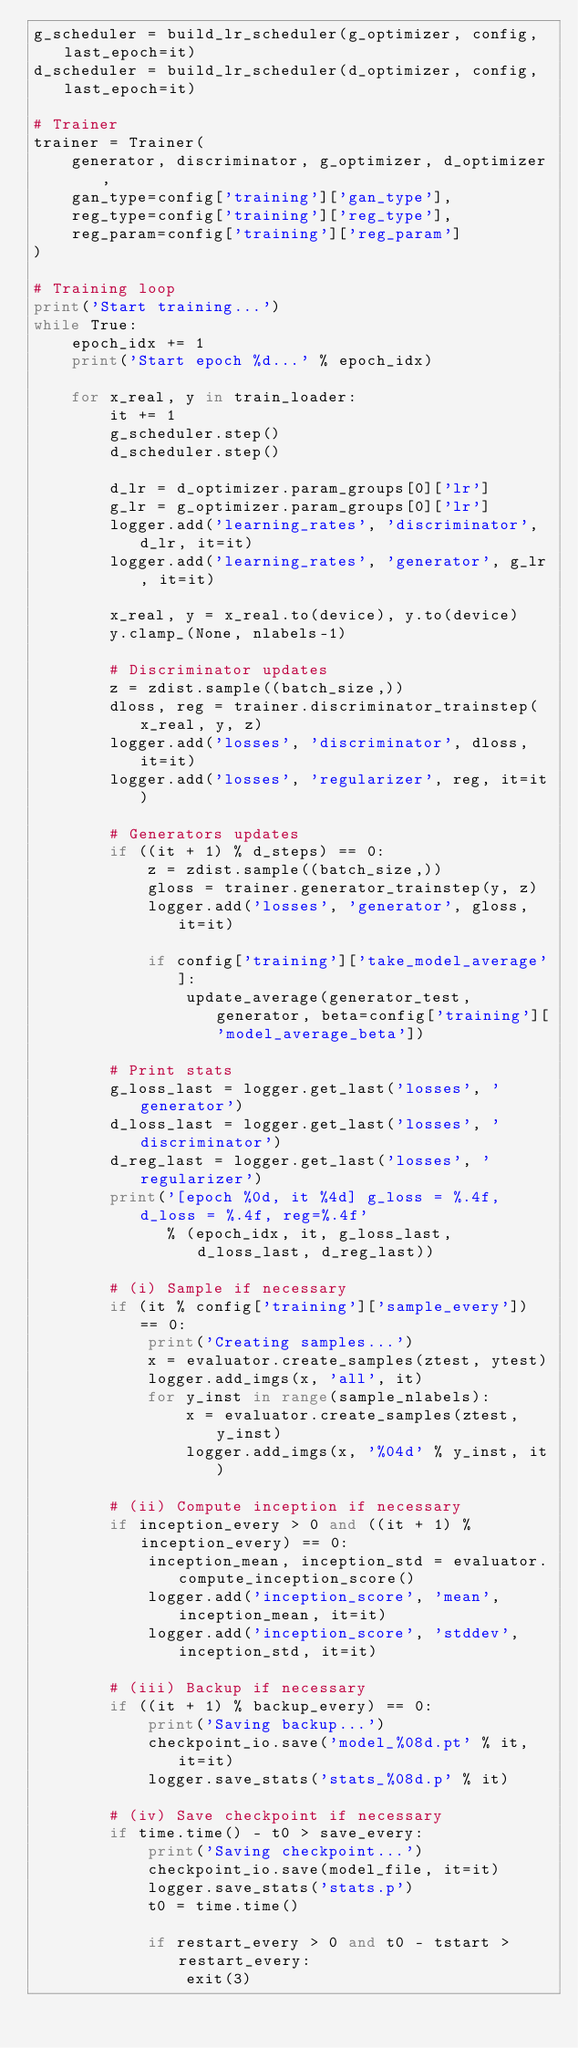Convert code to text. <code><loc_0><loc_0><loc_500><loc_500><_Python_>g_scheduler = build_lr_scheduler(g_optimizer, config, last_epoch=it)
d_scheduler = build_lr_scheduler(d_optimizer, config, last_epoch=it)

# Trainer
trainer = Trainer(
    generator, discriminator, g_optimizer, d_optimizer,
    gan_type=config['training']['gan_type'],
    reg_type=config['training']['reg_type'],
    reg_param=config['training']['reg_param']
)

# Training loop
print('Start training...')
while True:
    epoch_idx += 1
    print('Start epoch %d...' % epoch_idx)

    for x_real, y in train_loader:
        it += 1
        g_scheduler.step()
        d_scheduler.step()

        d_lr = d_optimizer.param_groups[0]['lr']
        g_lr = g_optimizer.param_groups[0]['lr']
        logger.add('learning_rates', 'discriminator', d_lr, it=it)
        logger.add('learning_rates', 'generator', g_lr, it=it)

        x_real, y = x_real.to(device), y.to(device)
        y.clamp_(None, nlabels-1)

        # Discriminator updates
        z = zdist.sample((batch_size,))
        dloss, reg = trainer.discriminator_trainstep(x_real, y, z)
        logger.add('losses', 'discriminator', dloss, it=it)
        logger.add('losses', 'regularizer', reg, it=it)

        # Generators updates
        if ((it + 1) % d_steps) == 0:
            z = zdist.sample((batch_size,))
            gloss = trainer.generator_trainstep(y, z)
            logger.add('losses', 'generator', gloss, it=it)

            if config['training']['take_model_average']:
                update_average(generator_test, generator, beta=config['training']['model_average_beta'])

        # Print stats
        g_loss_last = logger.get_last('losses', 'generator')
        d_loss_last = logger.get_last('losses', 'discriminator')
        d_reg_last = logger.get_last('losses', 'regularizer')
        print('[epoch %0d, it %4d] g_loss = %.4f, d_loss = %.4f, reg=%.4f'
              % (epoch_idx, it, g_loss_last, d_loss_last, d_reg_last))

        # (i) Sample if necessary
        if (it % config['training']['sample_every']) == 0:
            print('Creating samples...')
            x = evaluator.create_samples(ztest, ytest)
            logger.add_imgs(x, 'all', it)
            for y_inst in range(sample_nlabels):
                x = evaluator.create_samples(ztest, y_inst)
                logger.add_imgs(x, '%04d' % y_inst, it)

        # (ii) Compute inception if necessary
        if inception_every > 0 and ((it + 1) % inception_every) == 0:
            inception_mean, inception_std = evaluator.compute_inception_score()
            logger.add('inception_score', 'mean', inception_mean, it=it)
            logger.add('inception_score', 'stddev', inception_std, it=it)

        # (iii) Backup if necessary
        if ((it + 1) % backup_every) == 0:
            print('Saving backup...')
            checkpoint_io.save('model_%08d.pt' % it, it=it)
            logger.save_stats('stats_%08d.p' % it)

        # (iv) Save checkpoint if necessary
        if time.time() - t0 > save_every:
            print('Saving checkpoint...')
            checkpoint_io.save(model_file, it=it)
            logger.save_stats('stats.p')
            t0 = time.time()

            if restart_every > 0 and t0 - tstart > restart_every:
                exit(3)
</code> 